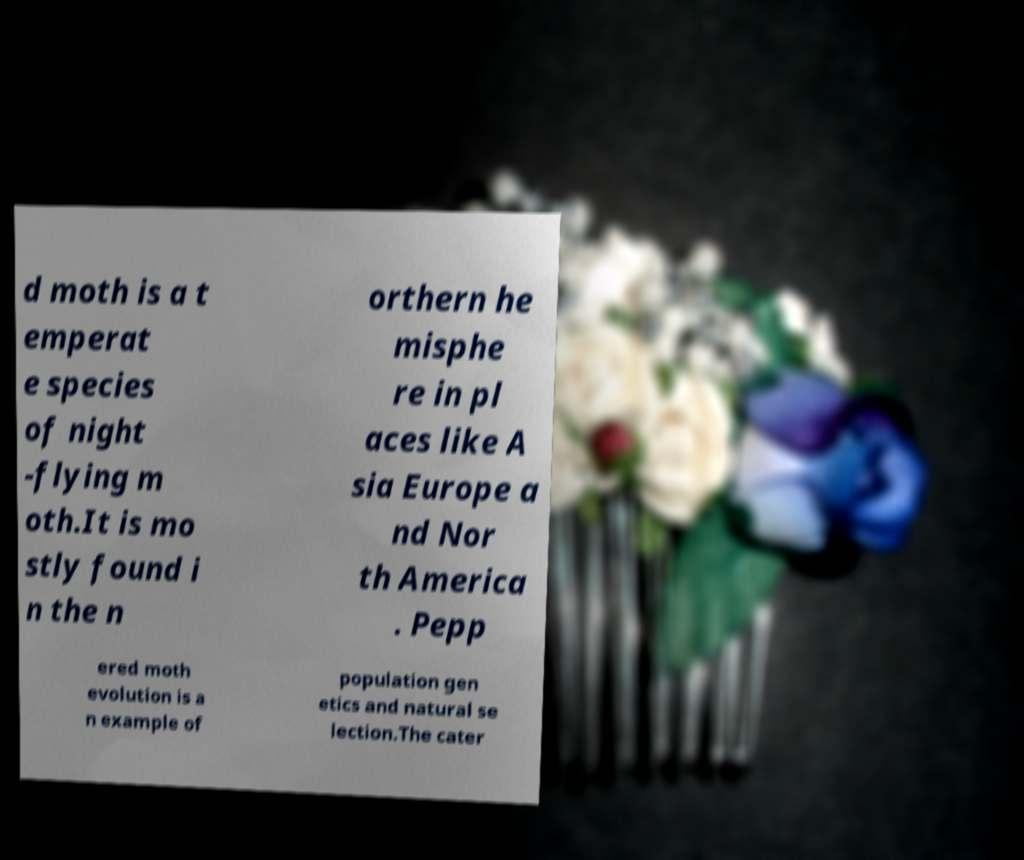Can you read and provide the text displayed in the image?This photo seems to have some interesting text. Can you extract and type it out for me? d moth is a t emperat e species of night -flying m oth.It is mo stly found i n the n orthern he misphe re in pl aces like A sia Europe a nd Nor th America . Pepp ered moth evolution is a n example of population gen etics and natural se lection.The cater 